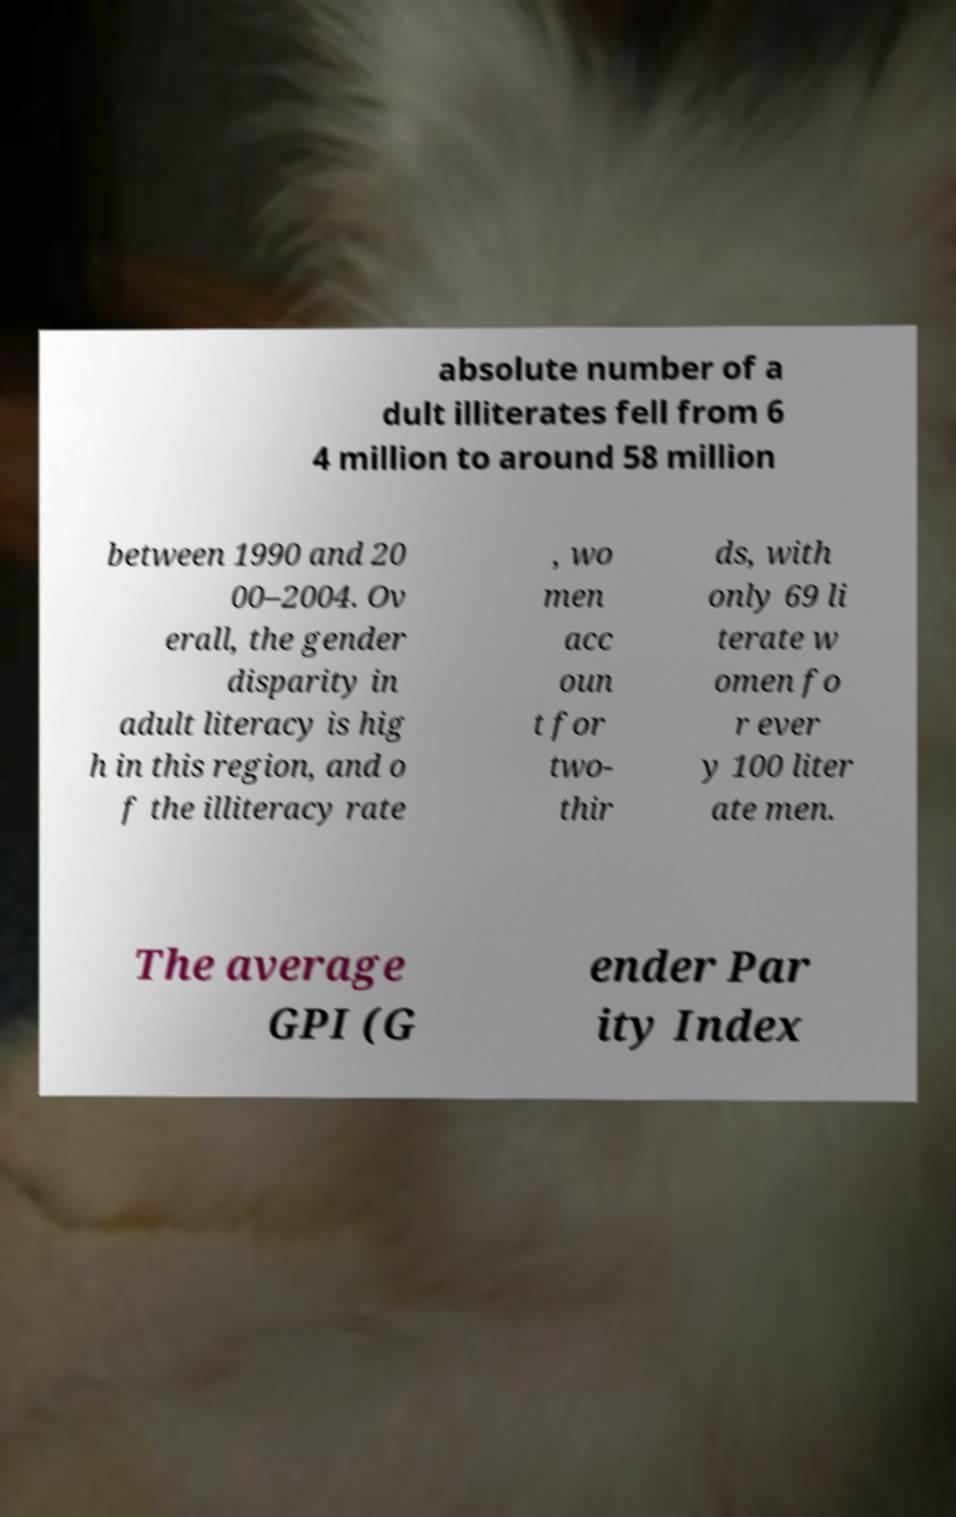For documentation purposes, I need the text within this image transcribed. Could you provide that? absolute number of a dult illiterates fell from 6 4 million to around 58 million between 1990 and 20 00–2004. Ov erall, the gender disparity in adult literacy is hig h in this region, and o f the illiteracy rate , wo men acc oun t for two- thir ds, with only 69 li terate w omen fo r ever y 100 liter ate men. The average GPI (G ender Par ity Index 